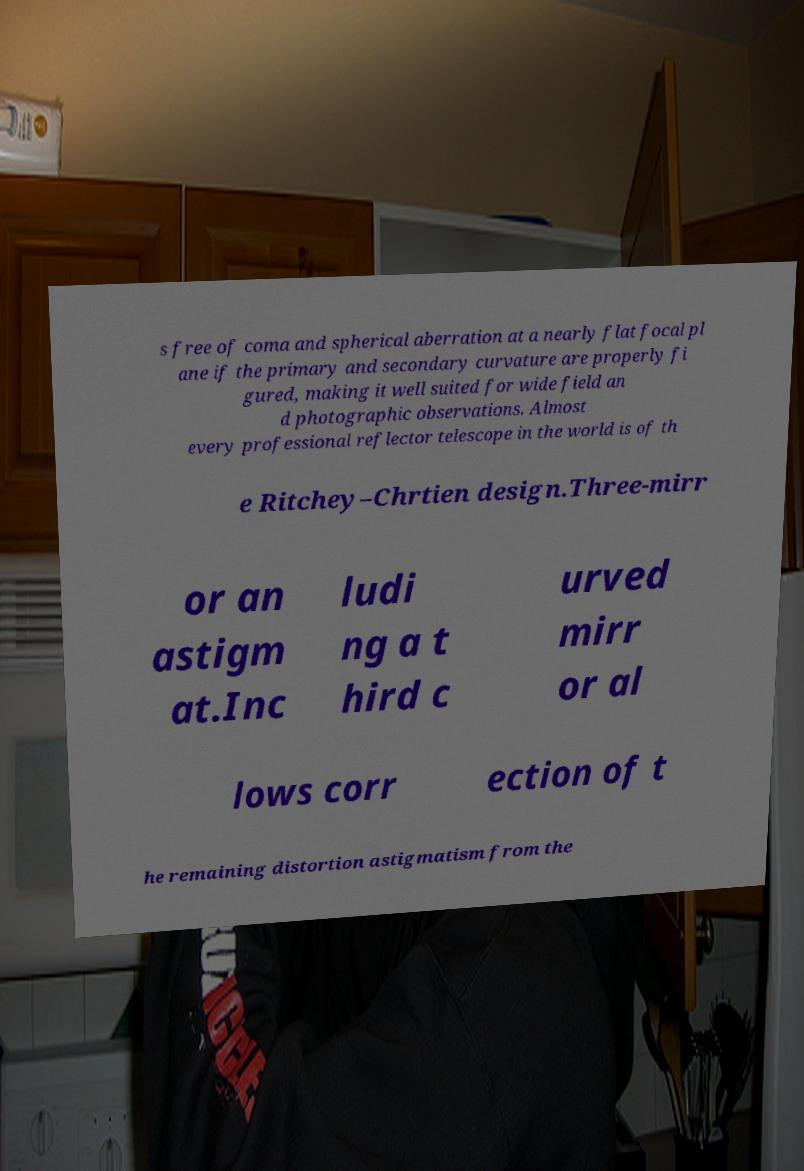For documentation purposes, I need the text within this image transcribed. Could you provide that? s free of coma and spherical aberration at a nearly flat focal pl ane if the primary and secondary curvature are properly fi gured, making it well suited for wide field an d photographic observations. Almost every professional reflector telescope in the world is of th e Ritchey–Chrtien design.Three-mirr or an astigm at.Inc ludi ng a t hird c urved mirr or al lows corr ection of t he remaining distortion astigmatism from the 